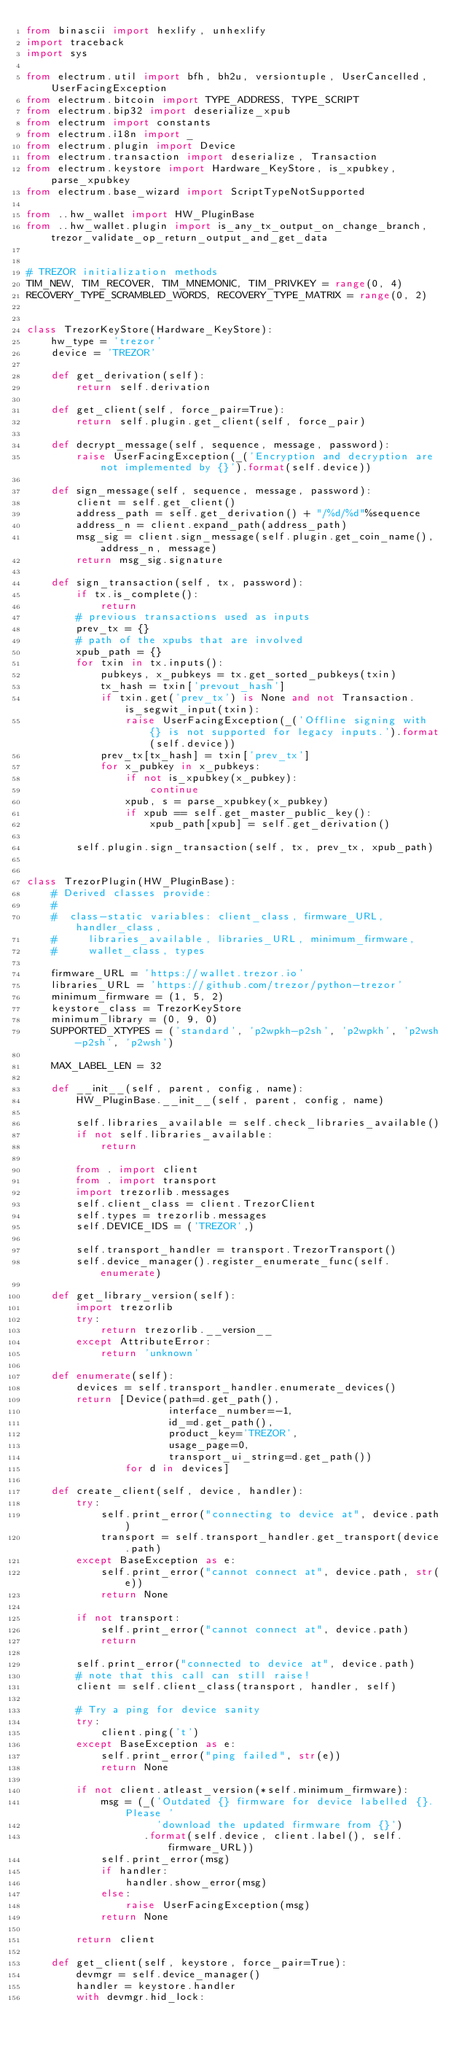<code> <loc_0><loc_0><loc_500><loc_500><_Python_>from binascii import hexlify, unhexlify
import traceback
import sys

from electrum.util import bfh, bh2u, versiontuple, UserCancelled, UserFacingException
from electrum.bitcoin import TYPE_ADDRESS, TYPE_SCRIPT
from electrum.bip32 import deserialize_xpub
from electrum import constants
from electrum.i18n import _
from electrum.plugin import Device
from electrum.transaction import deserialize, Transaction
from electrum.keystore import Hardware_KeyStore, is_xpubkey, parse_xpubkey
from electrum.base_wizard import ScriptTypeNotSupported

from ..hw_wallet import HW_PluginBase
from ..hw_wallet.plugin import is_any_tx_output_on_change_branch, trezor_validate_op_return_output_and_get_data


# TREZOR initialization methods
TIM_NEW, TIM_RECOVER, TIM_MNEMONIC, TIM_PRIVKEY = range(0, 4)
RECOVERY_TYPE_SCRAMBLED_WORDS, RECOVERY_TYPE_MATRIX = range(0, 2)


class TrezorKeyStore(Hardware_KeyStore):
    hw_type = 'trezor'
    device = 'TREZOR'

    def get_derivation(self):
        return self.derivation

    def get_client(self, force_pair=True):
        return self.plugin.get_client(self, force_pair)

    def decrypt_message(self, sequence, message, password):
        raise UserFacingException(_('Encryption and decryption are not implemented by {}').format(self.device))

    def sign_message(self, sequence, message, password):
        client = self.get_client()
        address_path = self.get_derivation() + "/%d/%d"%sequence
        address_n = client.expand_path(address_path)
        msg_sig = client.sign_message(self.plugin.get_coin_name(), address_n, message)
        return msg_sig.signature

    def sign_transaction(self, tx, password):
        if tx.is_complete():
            return
        # previous transactions used as inputs
        prev_tx = {}
        # path of the xpubs that are involved
        xpub_path = {}
        for txin in tx.inputs():
            pubkeys, x_pubkeys = tx.get_sorted_pubkeys(txin)
            tx_hash = txin['prevout_hash']
            if txin.get('prev_tx') is None and not Transaction.is_segwit_input(txin):
                raise UserFacingException(_('Offline signing with {} is not supported for legacy inputs.').format(self.device))
            prev_tx[tx_hash] = txin['prev_tx']
            for x_pubkey in x_pubkeys:
                if not is_xpubkey(x_pubkey):
                    continue
                xpub, s = parse_xpubkey(x_pubkey)
                if xpub == self.get_master_public_key():
                    xpub_path[xpub] = self.get_derivation()

        self.plugin.sign_transaction(self, tx, prev_tx, xpub_path)


class TrezorPlugin(HW_PluginBase):
    # Derived classes provide:
    #
    #  class-static variables: client_class, firmware_URL, handler_class,
    #     libraries_available, libraries_URL, minimum_firmware,
    #     wallet_class, types

    firmware_URL = 'https://wallet.trezor.io'
    libraries_URL = 'https://github.com/trezor/python-trezor'
    minimum_firmware = (1, 5, 2)
    keystore_class = TrezorKeyStore
    minimum_library = (0, 9, 0)
    SUPPORTED_XTYPES = ('standard', 'p2wpkh-p2sh', 'p2wpkh', 'p2wsh-p2sh', 'p2wsh')

    MAX_LABEL_LEN = 32

    def __init__(self, parent, config, name):
        HW_PluginBase.__init__(self, parent, config, name)

        self.libraries_available = self.check_libraries_available()
        if not self.libraries_available:
            return

        from . import client
        from . import transport
        import trezorlib.messages
        self.client_class = client.TrezorClient
        self.types = trezorlib.messages
        self.DEVICE_IDS = ('TREZOR',)

        self.transport_handler = transport.TrezorTransport()
        self.device_manager().register_enumerate_func(self.enumerate)

    def get_library_version(self):
        import trezorlib
        try:
            return trezorlib.__version__
        except AttributeError:
            return 'unknown'

    def enumerate(self):
        devices = self.transport_handler.enumerate_devices()
        return [Device(path=d.get_path(),
                       interface_number=-1,
                       id_=d.get_path(),
                       product_key='TREZOR',
                       usage_page=0,
                       transport_ui_string=d.get_path())
                for d in devices]

    def create_client(self, device, handler):
        try:
            self.print_error("connecting to device at", device.path)
            transport = self.transport_handler.get_transport(device.path)
        except BaseException as e:
            self.print_error("cannot connect at", device.path, str(e))
            return None

        if not transport:
            self.print_error("cannot connect at", device.path)
            return

        self.print_error("connected to device at", device.path)
        # note that this call can still raise!
        client = self.client_class(transport, handler, self)

        # Try a ping for device sanity
        try:
            client.ping('t')
        except BaseException as e:
            self.print_error("ping failed", str(e))
            return None

        if not client.atleast_version(*self.minimum_firmware):
            msg = (_('Outdated {} firmware for device labelled {}. Please '
                     'download the updated firmware from {}')
                   .format(self.device, client.label(), self.firmware_URL))
            self.print_error(msg)
            if handler:
                handler.show_error(msg)
            else:
                raise UserFacingException(msg)
            return None

        return client

    def get_client(self, keystore, force_pair=True):
        devmgr = self.device_manager()
        handler = keystore.handler
        with devmgr.hid_lock:</code> 